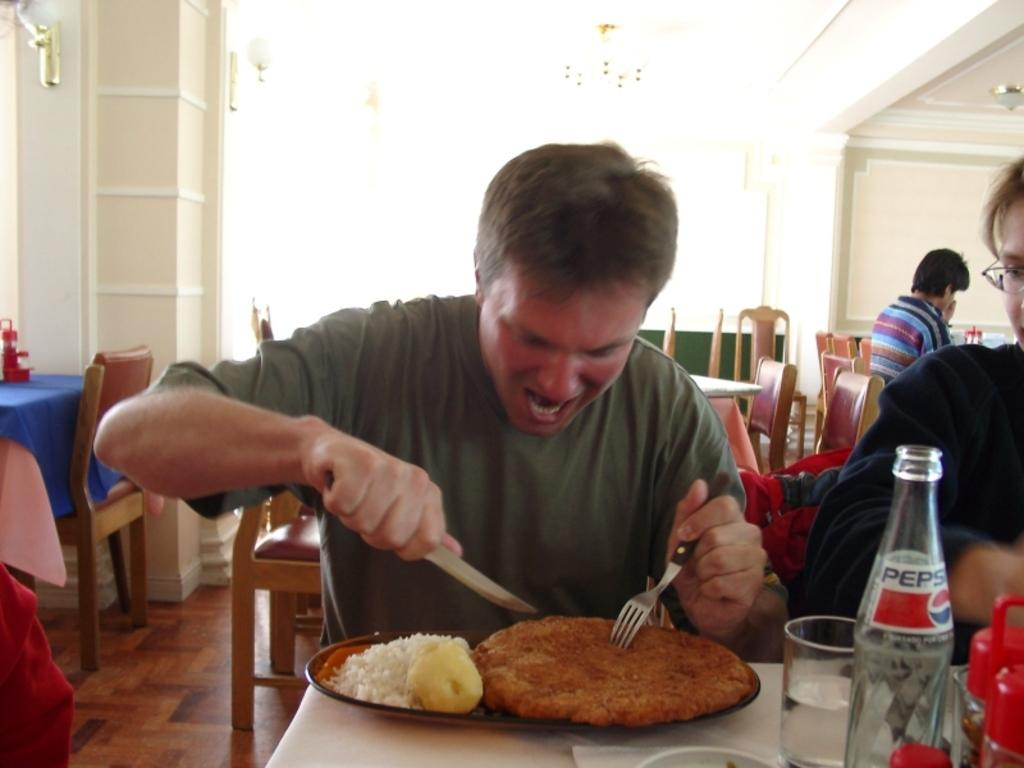<image>
Relay a brief, clear account of the picture shown. a man getting ready to eat a huge meal has a pepsi as well 